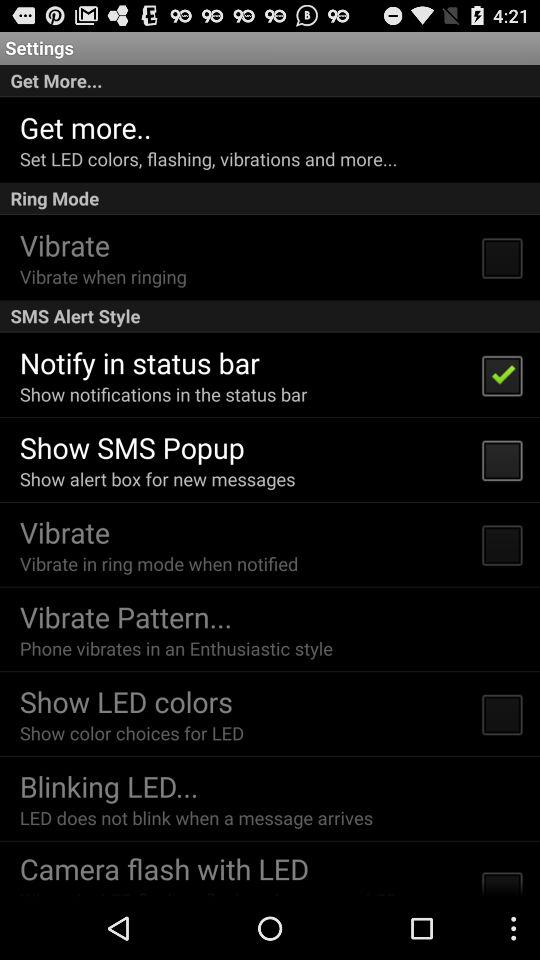What is the description of the "Vibrate Pattern"? The description of the "Vibrate Pattern" is "Phone vibrates in an Enthusiastic style". 